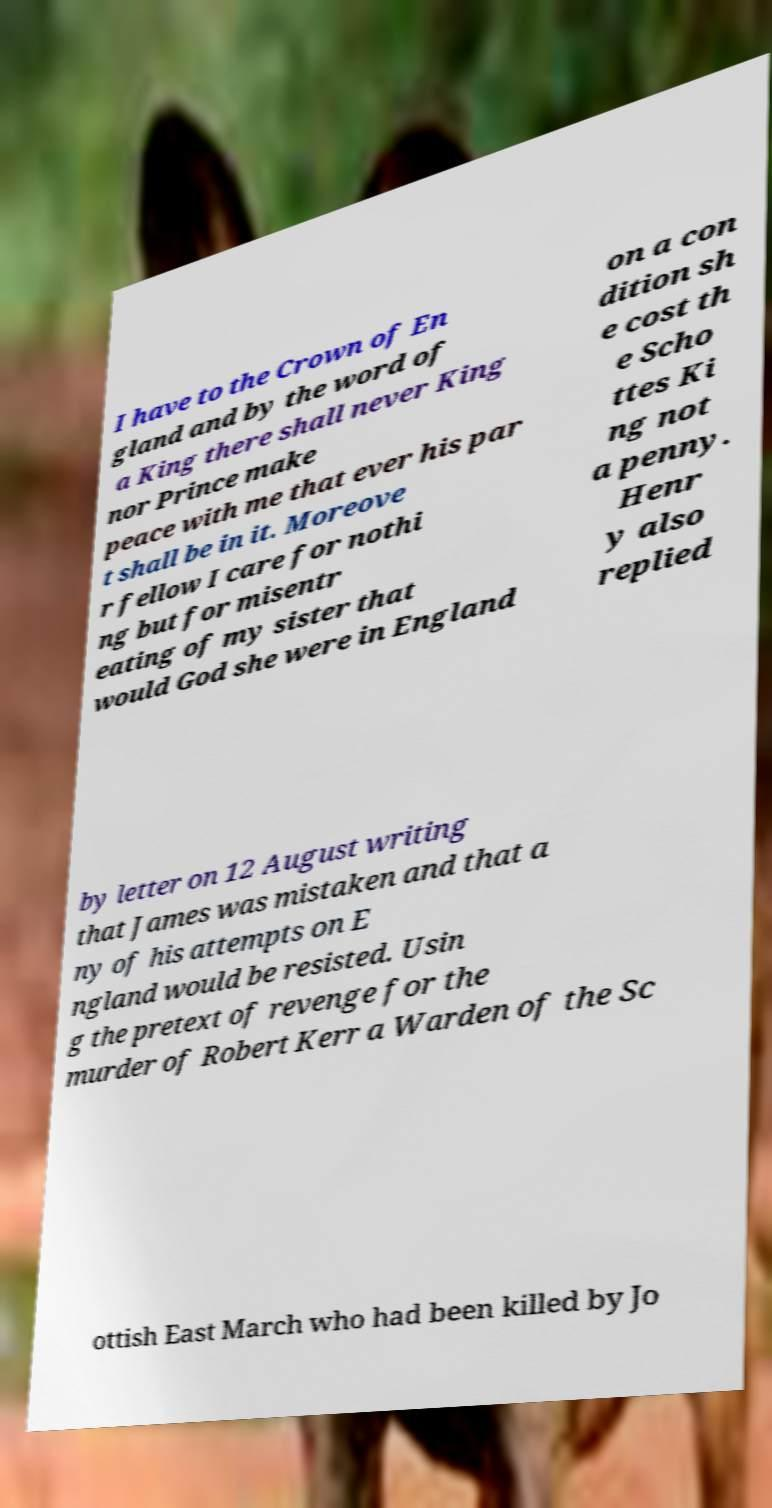For documentation purposes, I need the text within this image transcribed. Could you provide that? I have to the Crown of En gland and by the word of a King there shall never King nor Prince make peace with me that ever his par t shall be in it. Moreove r fellow I care for nothi ng but for misentr eating of my sister that would God she were in England on a con dition sh e cost th e Scho ttes Ki ng not a penny. Henr y also replied by letter on 12 August writing that James was mistaken and that a ny of his attempts on E ngland would be resisted. Usin g the pretext of revenge for the murder of Robert Kerr a Warden of the Sc ottish East March who had been killed by Jo 